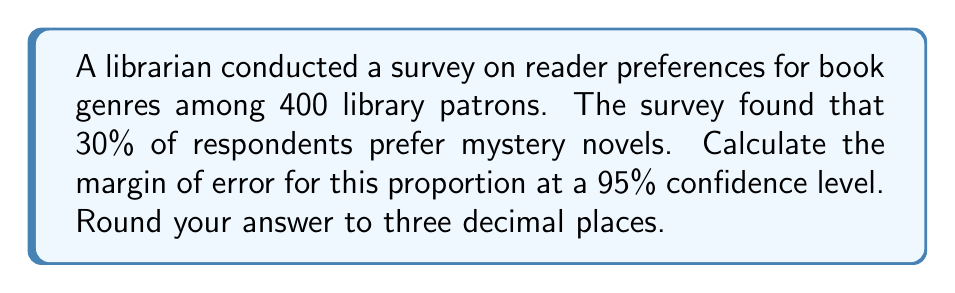Solve this math problem. To calculate the margin of error for a proportion, we use the following formula:

$$ \text{Margin of Error} = z \sqrt{\frac{p(1-p)}{n}} $$

Where:
$z$ is the z-score for the desired confidence level
$p$ is the sample proportion
$n$ is the sample size

Step 1: Determine the z-score for a 95% confidence level.
For a 95% confidence level, $z = 1.96$

Step 2: Identify the sample proportion and sample size.
$p = 0.30$ (30% prefer mystery novels)
$n = 400$ (total number of respondents)

Step 3: Plug the values into the formula.

$$ \text{Margin of Error} = 1.96 \sqrt{\frac{0.30(1-0.30)}{400}} $$

Step 4: Simplify the expression under the square root.

$$ \text{Margin of Error} = 1.96 \sqrt{\frac{0.30(0.70)}{400}} = 1.96 \sqrt{\frac{0.21}{400}} = 1.96 \sqrt{0.000525} $$

Step 5: Calculate the final result and round to three decimal places.

$$ \text{Margin of Error} = 1.96 \times 0.022913 = 0.044909 \approx 0.045 $$
Answer: 0.045 